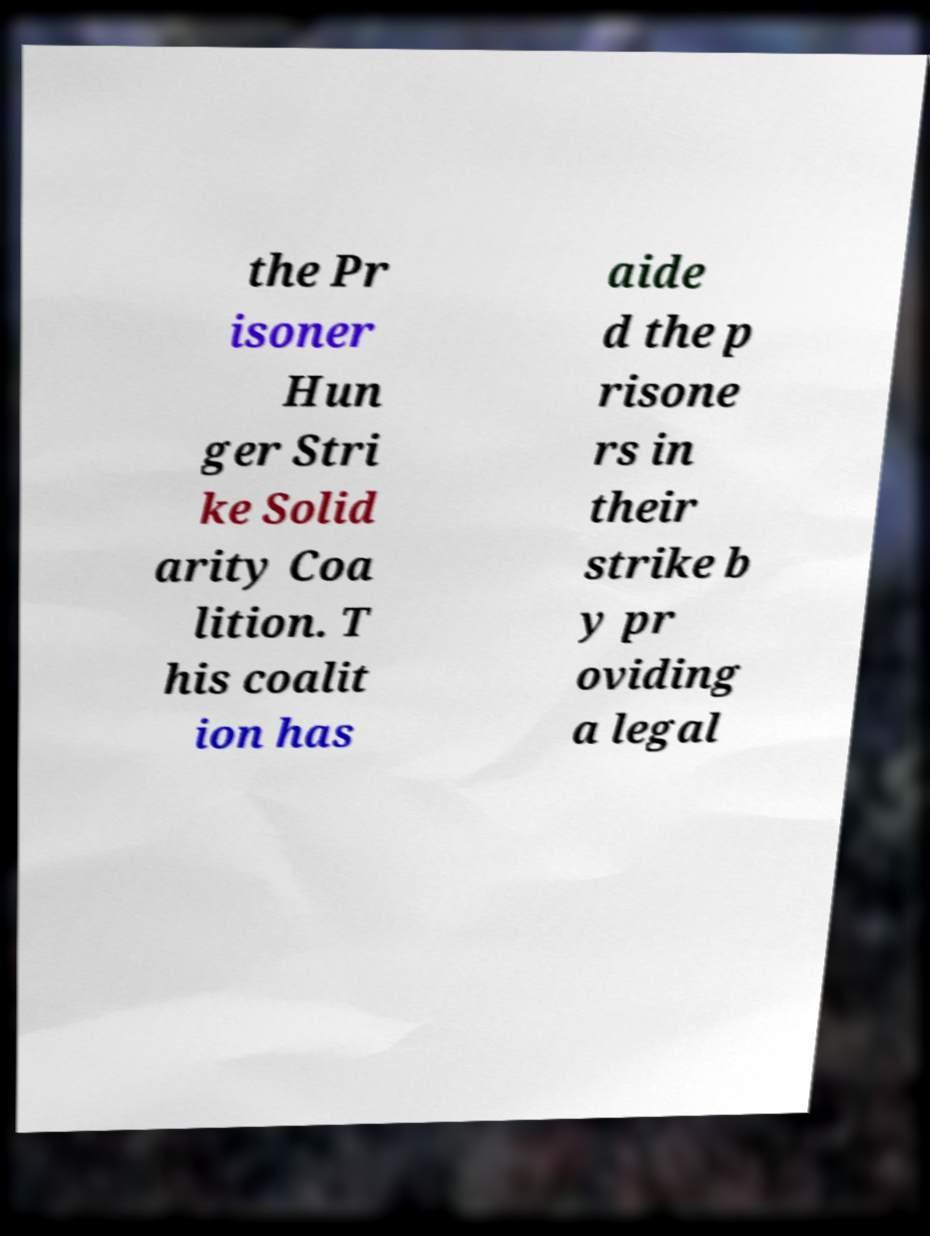There's text embedded in this image that I need extracted. Can you transcribe it verbatim? the Pr isoner Hun ger Stri ke Solid arity Coa lition. T his coalit ion has aide d the p risone rs in their strike b y pr oviding a legal 